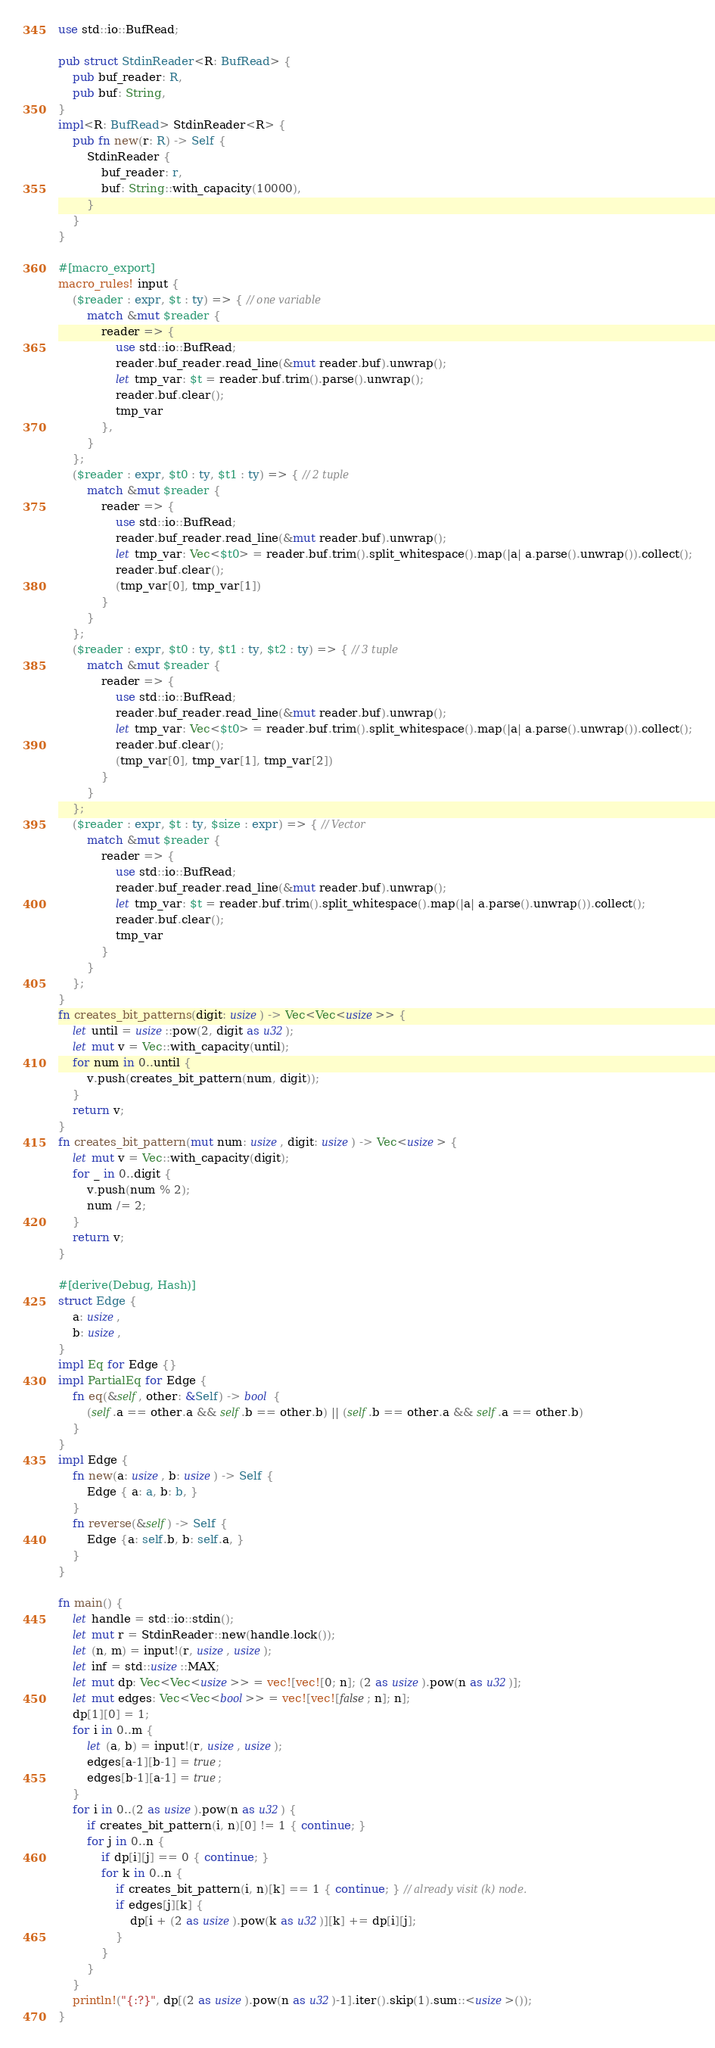Convert code to text. <code><loc_0><loc_0><loc_500><loc_500><_Rust_>use std::io::BufRead;

pub struct StdinReader<R: BufRead> {
    pub buf_reader: R,
    pub buf: String,
}
impl<R: BufRead> StdinReader<R> {
    pub fn new(r: R) -> Self {
        StdinReader {
            buf_reader: r,
            buf: String::with_capacity(10000),
        }
    }
}

#[macro_export]
macro_rules! input {
    ($reader : expr, $t : ty) => { // one variable
        match &mut $reader {
            reader => {
                use std::io::BufRead;
                reader.buf_reader.read_line(&mut reader.buf).unwrap();
                let tmp_var: $t = reader.buf.trim().parse().unwrap(); 
                reader.buf.clear();
                tmp_var
            },
        }
    };
    ($reader : expr, $t0 : ty, $t1 : ty) => { // 2 tuple
        match &mut $reader {
            reader => {
                use std::io::BufRead;
                reader.buf_reader.read_line(&mut reader.buf).unwrap();
                let tmp_var: Vec<$t0> = reader.buf.trim().split_whitespace().map(|a| a.parse().unwrap()).collect();
                reader.buf.clear();
                (tmp_var[0], tmp_var[1])
            }
        }
    };
    ($reader : expr, $t0 : ty, $t1 : ty, $t2 : ty) => { // 3 tuple
        match &mut $reader {
            reader => {
                use std::io::BufRead;
                reader.buf_reader.read_line(&mut reader.buf).unwrap();
                let tmp_var: Vec<$t0> = reader.buf.trim().split_whitespace().map(|a| a.parse().unwrap()).collect();
                reader.buf.clear();
                (tmp_var[0], tmp_var[1], tmp_var[2])
            }
        }
    };
    ($reader : expr, $t : ty, $size : expr) => { // Vector
        match &mut $reader {
            reader => {
                use std::io::BufRead;
                reader.buf_reader.read_line(&mut reader.buf).unwrap();
                let tmp_var: $t = reader.buf.trim().split_whitespace().map(|a| a.parse().unwrap()).collect();
                reader.buf.clear();
                tmp_var
            }
        }
    };
}
fn creates_bit_patterns(digit: usize) -> Vec<Vec<usize>> {
    let until = usize::pow(2, digit as u32);
    let mut v = Vec::with_capacity(until);
    for num in 0..until {
        v.push(creates_bit_pattern(num, digit));
    }
    return v;
}
fn creates_bit_pattern(mut num: usize, digit: usize) -> Vec<usize> {
    let mut v = Vec::with_capacity(digit);
    for _ in 0..digit {
        v.push(num % 2);
        num /= 2;
    }
    return v;
}

#[derive(Debug, Hash)]
struct Edge {
    a: usize,
    b: usize,
}
impl Eq for Edge {}
impl PartialEq for Edge {
    fn eq(&self, other: &Self) -> bool {
        (self.a == other.a && self.b == other.b) || (self.b == other.a && self.a == other.b)
    }
}
impl Edge {
    fn new(a: usize, b: usize) -> Self {
        Edge { a: a, b: b, }
    }
    fn reverse(&self) -> Self {
        Edge {a: self.b, b: self.a, }
    }
}

fn main() {
    let handle = std::io::stdin();
    let mut r = StdinReader::new(handle.lock());
    let (n, m) = input!(r, usize, usize);
    let inf = std::usize::MAX;
    let mut dp: Vec<Vec<usize>> = vec![vec![0; n]; (2 as usize).pow(n as u32)];
    let mut edges: Vec<Vec<bool>> = vec![vec![false; n]; n];
    dp[1][0] = 1;
    for i in 0..m {
        let (a, b) = input!(r, usize, usize);
        edges[a-1][b-1] = true;
        edges[b-1][a-1] = true;
    }
    for i in 0..(2 as usize).pow(n as u32) {
        if creates_bit_pattern(i, n)[0] != 1 { continue; }
        for j in 0..n {
            if dp[i][j] == 0 { continue; }
            for k in 0..n {
                if creates_bit_pattern(i, n)[k] == 1 { continue; } // already visit (k) node.
                if edges[j][k] {
                    dp[i + (2 as usize).pow(k as u32)][k] += dp[i][j];
                }
            }
        }
    }
    println!("{:?}", dp[(2 as usize).pow(n as u32)-1].iter().skip(1).sum::<usize>());
}
</code> 